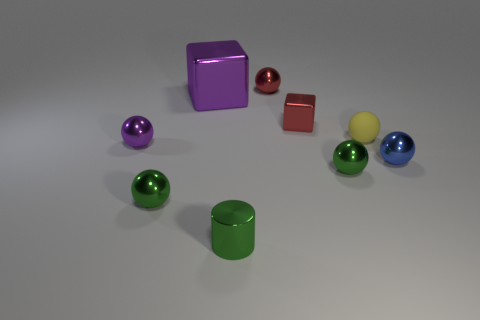Is the number of tiny things that are behind the large purple block greater than the number of tiny blue spheres that are behind the tiny yellow rubber ball?
Ensure brevity in your answer.  Yes. How many other things are there of the same color as the small metallic cylinder?
Offer a very short reply. 2. Does the small block have the same color as the small metal ball behind the purple ball?
Offer a very short reply. Yes. There is a tiny ball behind the rubber sphere; how many small rubber things are to the right of it?
Offer a terse response. 1. Is there anything else that has the same material as the tiny yellow thing?
Provide a short and direct response. No. What material is the red object that is behind the tiny red metallic object in front of the purple metallic object behind the purple sphere?
Ensure brevity in your answer.  Metal. There is a small ball that is on the left side of the small block and in front of the small purple shiny ball; what material is it?
Ensure brevity in your answer.  Metal. What number of other tiny yellow objects are the same shape as the yellow object?
Provide a short and direct response. 0. There is a red thing that is behind the shiny block that is to the right of the big cube; what is its size?
Ensure brevity in your answer.  Small. There is a tiny shiny ball behind the purple metal cube; does it have the same color as the sphere that is on the right side of the small matte object?
Offer a very short reply. No. 